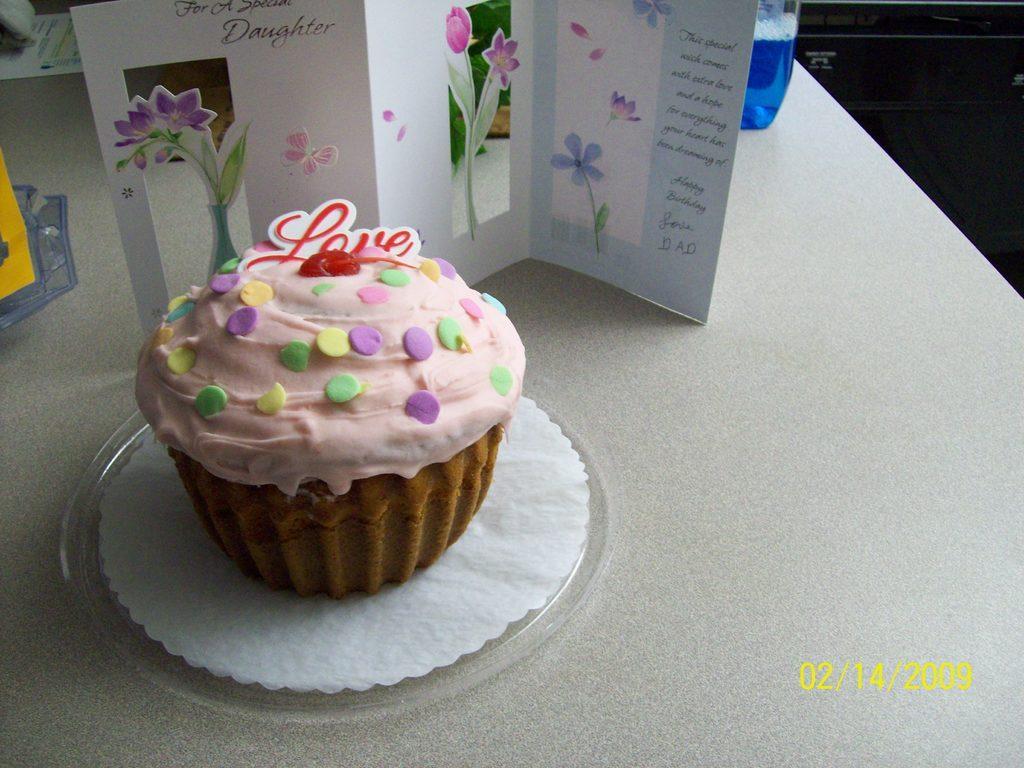How would you summarize this image in a sentence or two? In this image there is a cupcake on a lid with a greeting card beside it and there is an object and a bottle with blue liquid on the table, at the bottom of the image there is date. 